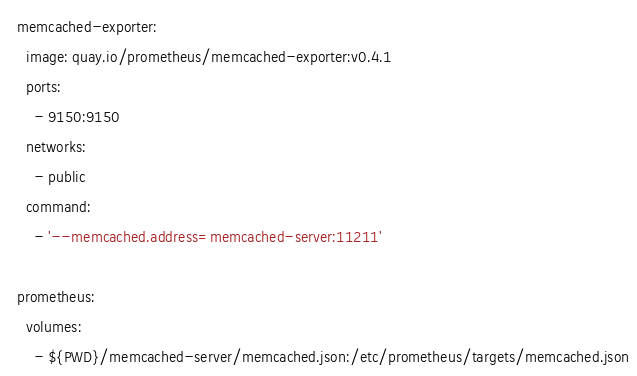<code> <loc_0><loc_0><loc_500><loc_500><_YAML_>  memcached-exporter:
    image: quay.io/prometheus/memcached-exporter:v0.4.1
    ports:
      - 9150:9150
    networks:
      - public
    command:
      - '--memcached.address=memcached-server:11211'

  prometheus:
    volumes:
      - ${PWD}/memcached-server/memcached.json:/etc/prometheus/targets/memcached.json

</code> 